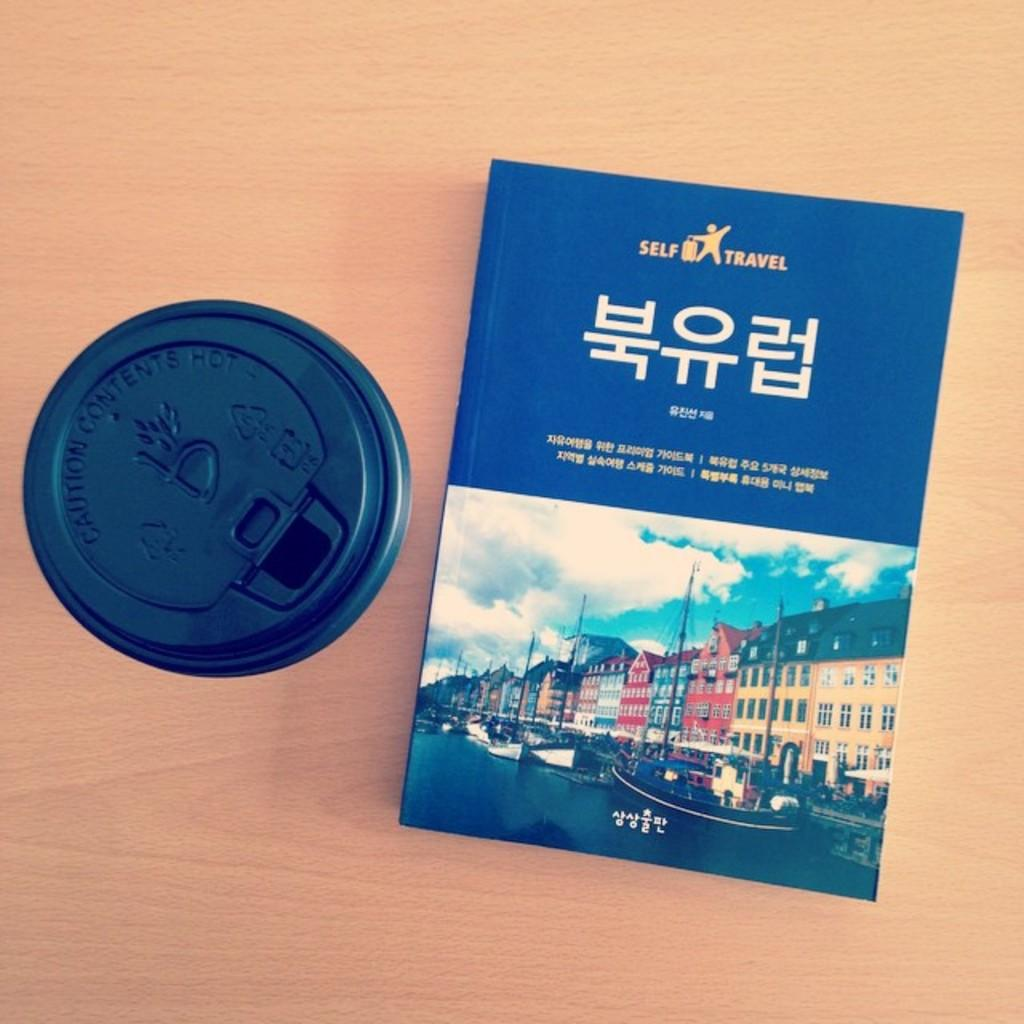<image>
Describe the image concisely. A self travel book sits next to a plastic coffee cup 